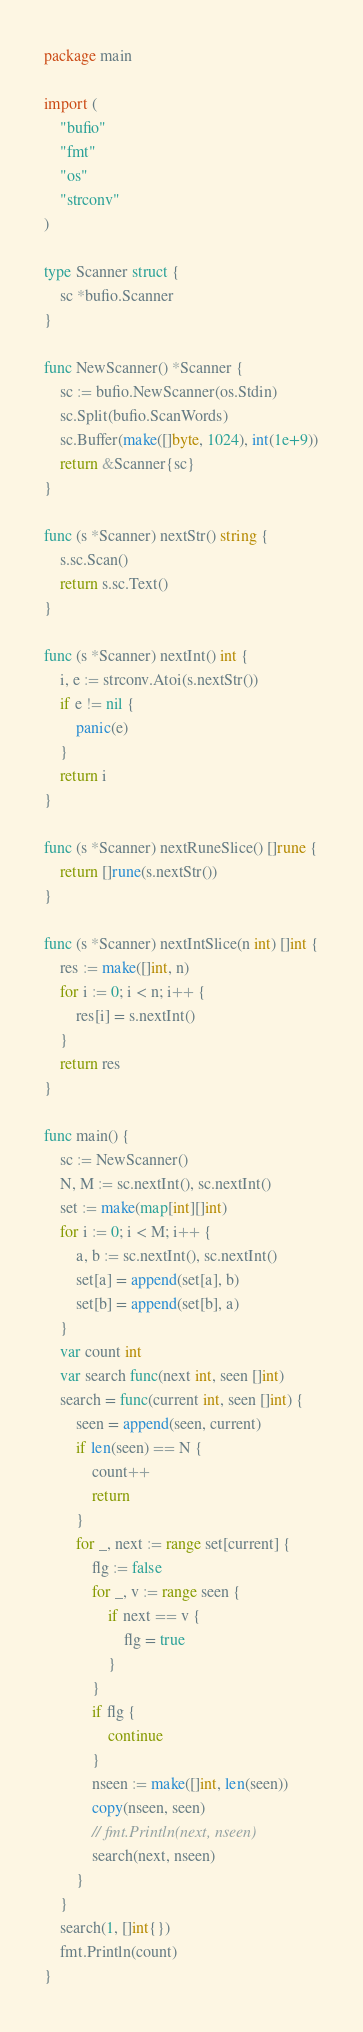<code> <loc_0><loc_0><loc_500><loc_500><_Go_>package main

import (
	"bufio"
	"fmt"
	"os"
	"strconv"
)

type Scanner struct {
	sc *bufio.Scanner
}

func NewScanner() *Scanner {
	sc := bufio.NewScanner(os.Stdin)
	sc.Split(bufio.ScanWords)
	sc.Buffer(make([]byte, 1024), int(1e+9))
	return &Scanner{sc}
}

func (s *Scanner) nextStr() string {
	s.sc.Scan()
	return s.sc.Text()
}

func (s *Scanner) nextInt() int {
	i, e := strconv.Atoi(s.nextStr())
	if e != nil {
		panic(e)
	}
	return i
}

func (s *Scanner) nextRuneSlice() []rune {
	return []rune(s.nextStr())
}

func (s *Scanner) nextIntSlice(n int) []int {
	res := make([]int, n)
	for i := 0; i < n; i++ {
		res[i] = s.nextInt()
	}
	return res
}

func main() {
	sc := NewScanner()
	N, M := sc.nextInt(), sc.nextInt()
	set := make(map[int][]int)
	for i := 0; i < M; i++ {
		a, b := sc.nextInt(), sc.nextInt()
		set[a] = append(set[a], b)
		set[b] = append(set[b], a)
	}
	var count int
	var search func(next int, seen []int)
	search = func(current int, seen []int) {
		seen = append(seen, current)
		if len(seen) == N {
			count++
			return
		}
		for _, next := range set[current] {
			flg := false
			for _, v := range seen {
				if next == v {
					flg = true
				}
			}
			if flg {
				continue
			}
			nseen := make([]int, len(seen))
			copy(nseen, seen)
			// fmt.Println(next, nseen)
			search(next, nseen)
		}
	}
	search(1, []int{})
	fmt.Println(count)
}
</code> 